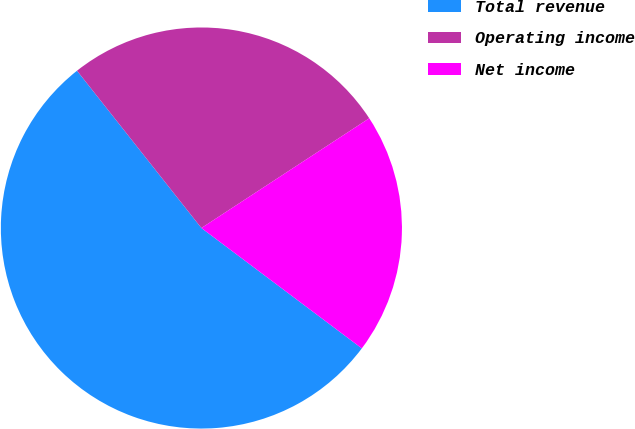Convert chart to OTSL. <chart><loc_0><loc_0><loc_500><loc_500><pie_chart><fcel>Total revenue<fcel>Operating income<fcel>Net income<nl><fcel>54.1%<fcel>26.43%<fcel>19.46%<nl></chart> 